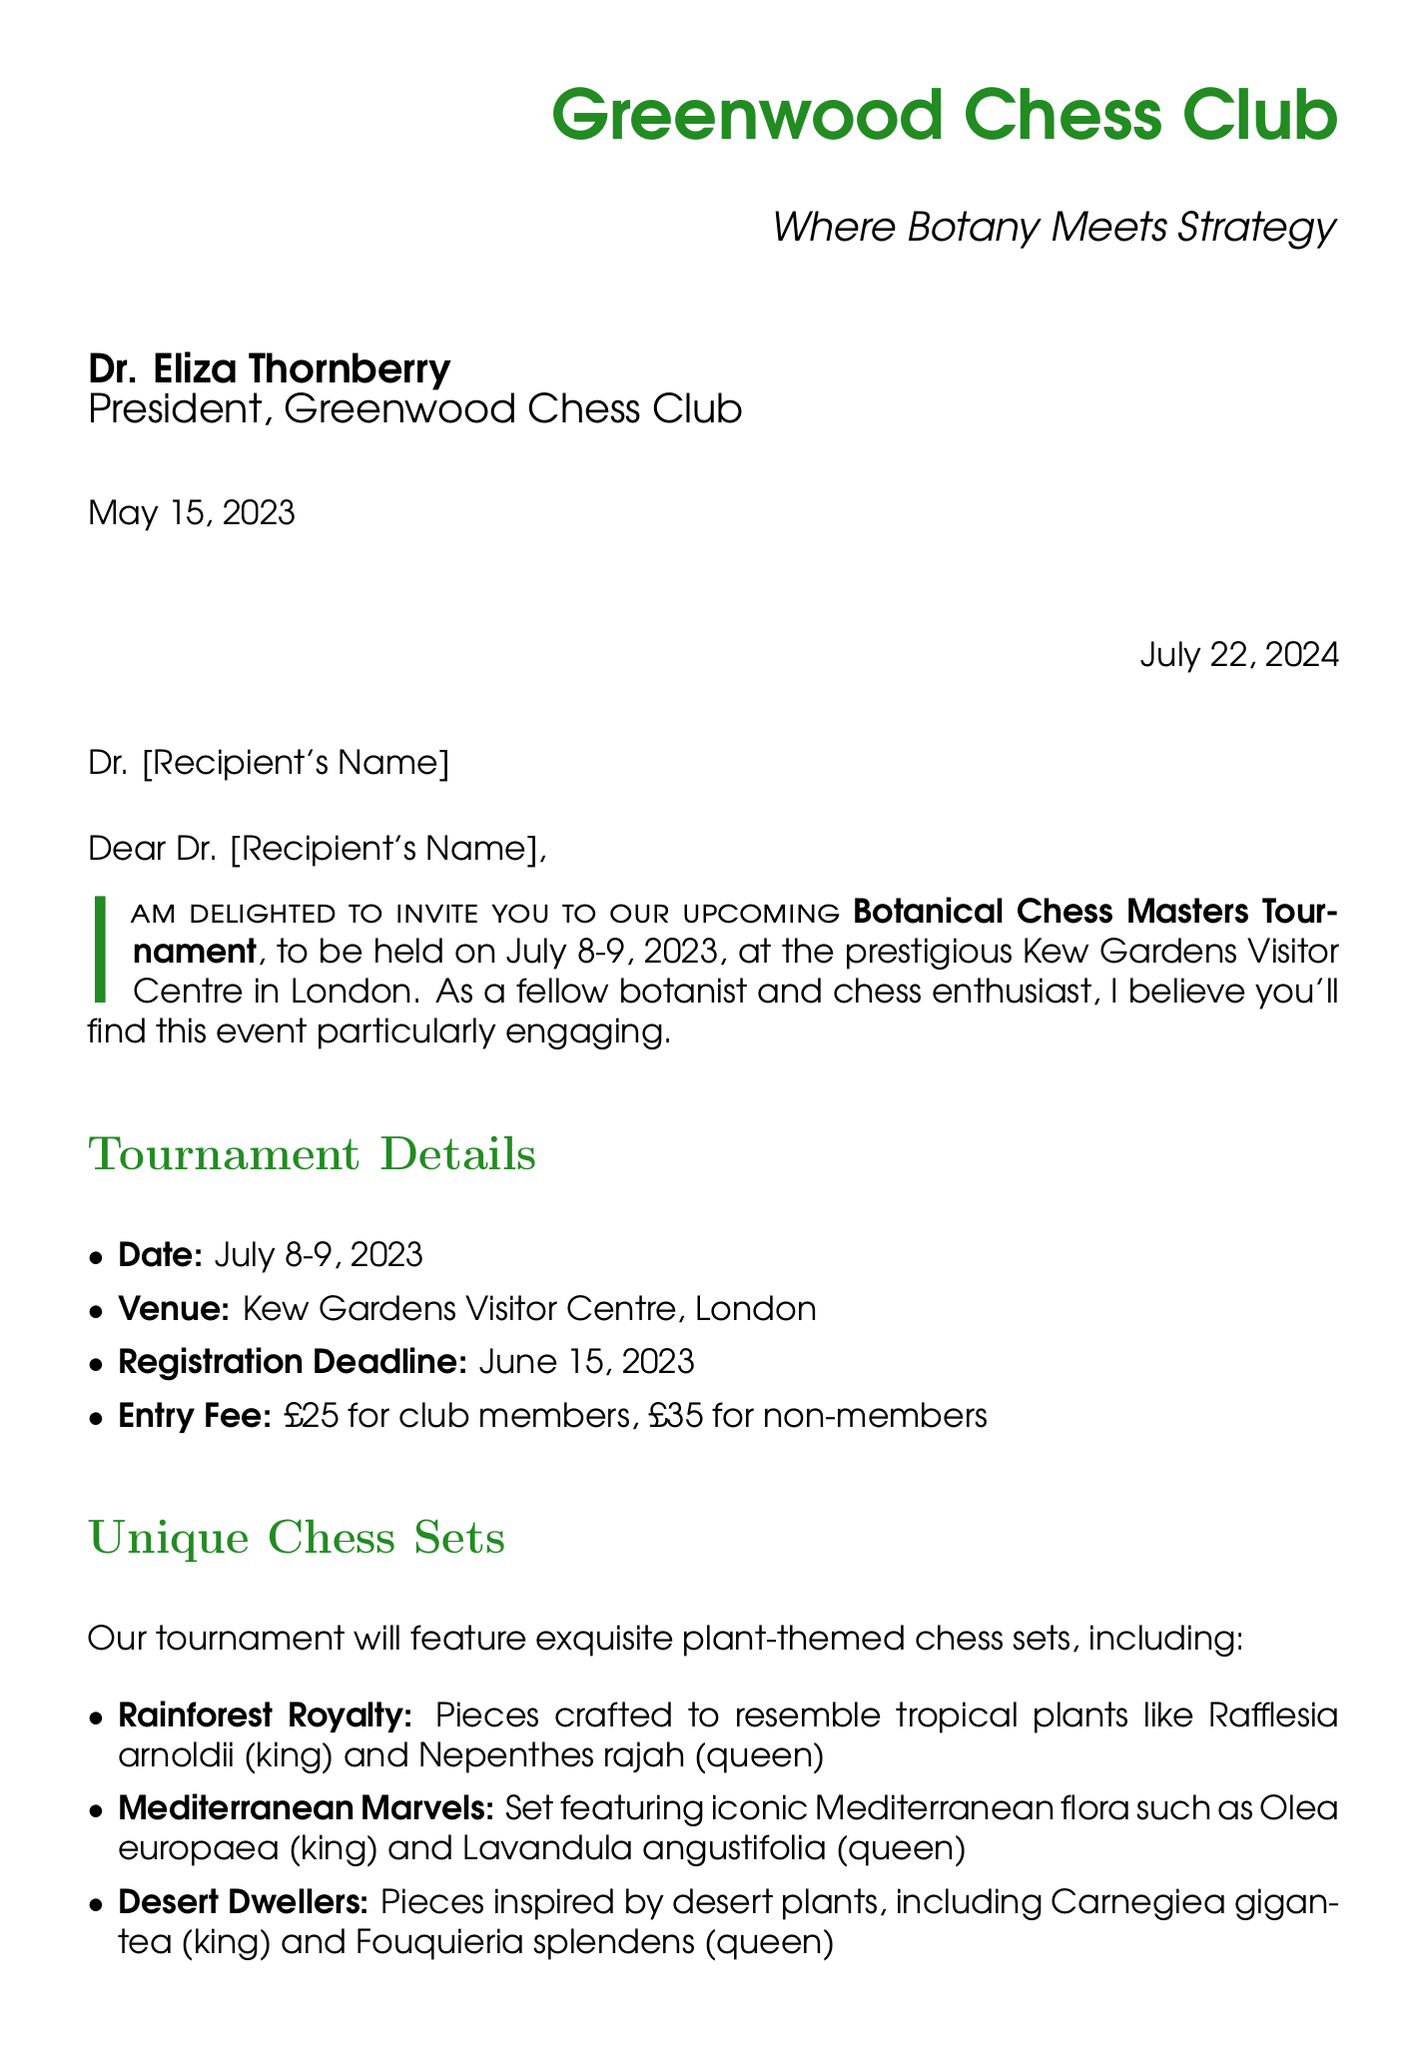What is the name of the tournament? The tournament is referred to as the Botanical Chess Masters Tournament in the document.
Answer: Botanical Chess Masters Tournament Who is the guest speaker for the event? The document mentions Grandmaster Garry Kasparov as the guest speaker.
Answer: Grandmaster Garry Kasparov What is the entry fee for non-members? The document states the entry fee for non-members is £35.
Answer: £35 On what dates will the tournament be held? The tournament is scheduled for July 8-9, 2023, according to the document.
Answer: July 8-9, 2023 What is one of the special events included in the tournament? The document lists "Botanical Blitz" as one of the special events.
Answer: Botanical Blitz How many prizes are there for the tournament winners? The document details three prizes for the tournament winners.
Answer: Three What is the registration deadline for the tournament? The registration deadline is specified as June 15, 2023, in the document.
Answer: June 15, 2023 What accommodations are available for tournament participants? The document mentions discounted rates at the Richmond Hill Hotel for participants.
Answer: Richmond Hill Hotel What will participants receive for finishing in 1st place? According to the document, the 1st place prize is a handcrafted botanical chess set and annual membership to the Royal Botanic Gardens, Kew.
Answer: Handcrafted botanical chess set and annual membership to the Royal Botanic Gardens, Kew 